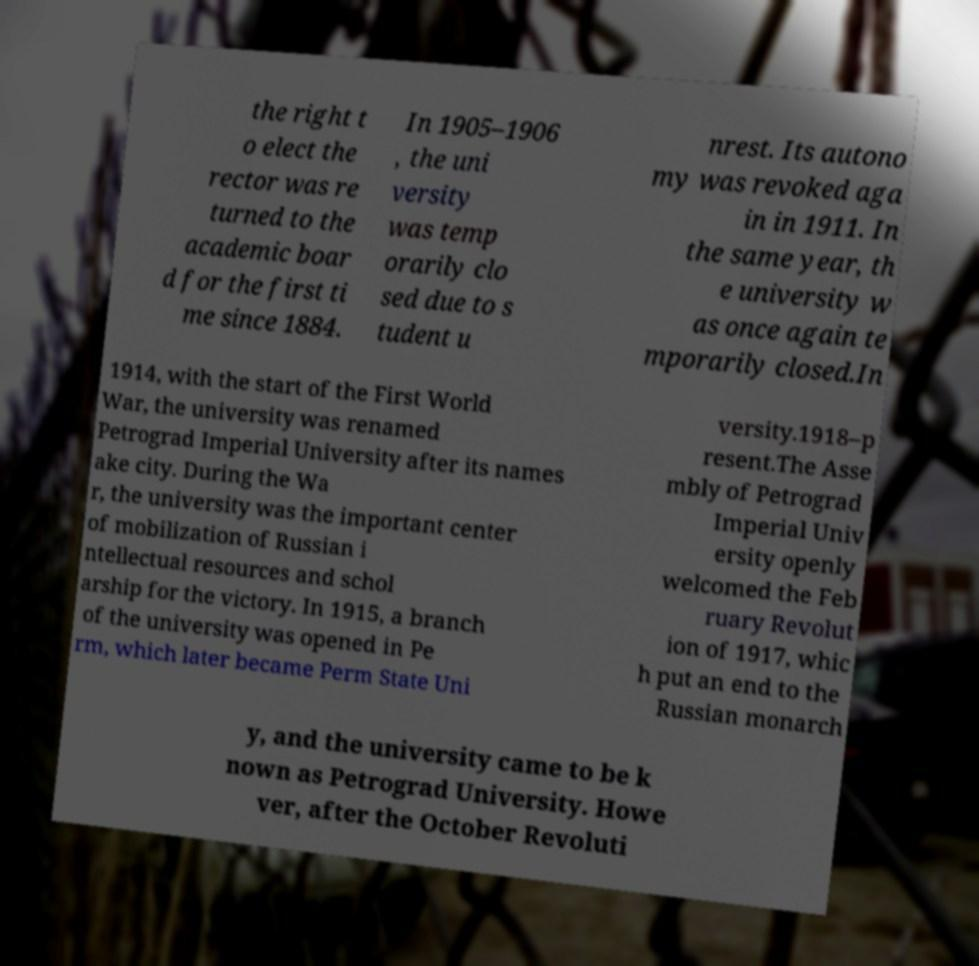Can you read and provide the text displayed in the image?This photo seems to have some interesting text. Can you extract and type it out for me? the right t o elect the rector was re turned to the academic boar d for the first ti me since 1884. In 1905–1906 , the uni versity was temp orarily clo sed due to s tudent u nrest. Its autono my was revoked aga in in 1911. In the same year, th e university w as once again te mporarily closed.In 1914, with the start of the First World War, the university was renamed Petrograd Imperial University after its names ake city. During the Wa r, the university was the important center of mobilization of Russian i ntellectual resources and schol arship for the victory. In 1915, a branch of the university was opened in Pe rm, which later became Perm State Uni versity.1918–p resent.The Asse mbly of Petrograd Imperial Univ ersity openly welcomed the Feb ruary Revolut ion of 1917, whic h put an end to the Russian monarch y, and the university came to be k nown as Petrograd University. Howe ver, after the October Revoluti 